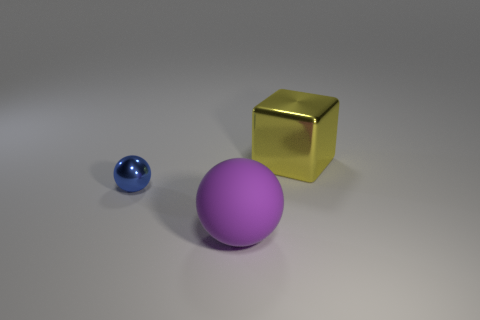Are there any other things that have the same size as the metallic sphere?
Offer a terse response. No. There is a shiny object that is in front of the shiny cube; are there any big metallic things that are on the left side of it?
Ensure brevity in your answer.  No. What number of other things are the same color as the matte sphere?
Offer a very short reply. 0. What color is the small metallic thing?
Provide a short and direct response. Blue. There is a thing that is behind the matte sphere and to the left of the large metal object; how big is it?
Provide a short and direct response. Small. How many things are objects on the left side of the big metallic block or big blocks?
Keep it short and to the point. 3. There is another object that is made of the same material as the yellow object; what is its shape?
Your answer should be very brief. Sphere. The blue thing has what shape?
Your answer should be compact. Sphere. There is a thing that is to the right of the blue metallic sphere and behind the matte sphere; what is its color?
Provide a short and direct response. Yellow. There is a yellow shiny thing that is the same size as the rubber thing; what shape is it?
Make the answer very short. Cube. 